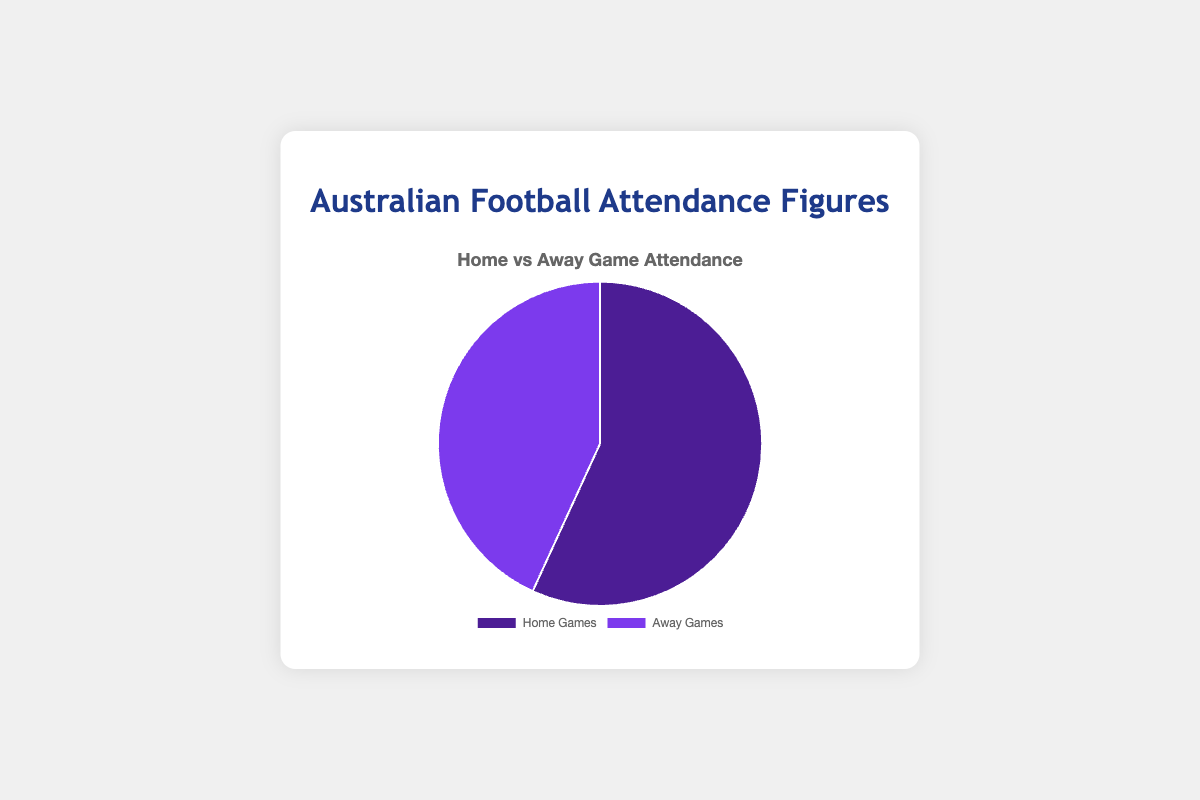What is the total attendance for both Home Games and Away Games? Sum the attendances for Home Games and Away Games: 125000 + 95000. The total attendance is 220000 spectators.
Answer: 220000 Which type of game had higher attendance? Compare the attendance figures directly from the pie chart: Home Games had 125000 spectators, whereas Away Games had 95000 spectators. Home Games had higher attendance.
Answer: Home Games What percentage of the total attendance is for Away Games? Calculate the percentage by dividing the Away Games attendance by the total attendance and multiplying by 100: (95000 / 220000) * 100. The percentage for Away Games is approximately 43.18%.
Answer: 43.18% By how much did the Home Games attendance exceed the Away Games attendance? Subtract the Away Games attendance from the Home Games attendance: 125000 - 95000. The Home Games exceeded by 30000 spectators.
Answer: 30000 What is the difference in the proportion of attendance between Home Games and Away Games? Calculate the proportions as percentages of the total: Home Games (57.18%) and Away Games (43.18%). The difference is 57.18% - 43.18%. The proportion difference is approximately 14%.
Answer: 14% Describe the colors used in the pie chart to distinguish between Home Games and Away Games? The Home Games section is represented by a darker shade of purple, and the Away Games section by a lighter shade of purple.
Answer: Darker purple for Home Games, lighter purple for Away Games If the total attendance increased by 10%, what would the new attendance figures be for Home Games and Away Games, assuming the same ratio? First, calculate the new total attendance: 220000 * 1.10 = 242000. The ratio of Home to Away is 125000:95000. Calculate new figures maintaining the ratio: (125000/220000) * 242000 ≈ 137500 and (95000/220000) * 242000 ≈ 104500. New figures are approximately 137500 for Home Games and 104500 for Away Games.
Answer: 137500 for Home Games and 104500 for Away Games If each away game on average had 5000 spectators, how many away games were there? Divide the total Away Games attendance by the average spectators per game: 95000 / 5000. There were 19 away games.
Answer: 19 